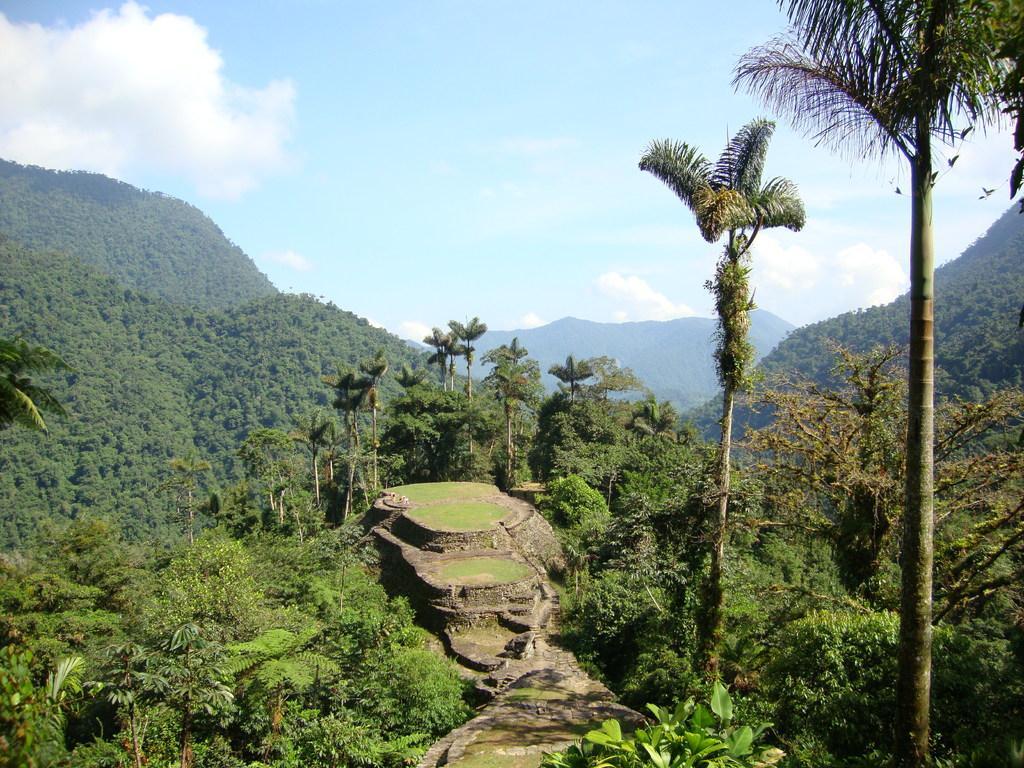Can you describe this image briefly? In this picture I can see trees and I can see hills and a blue cloudy sky. 